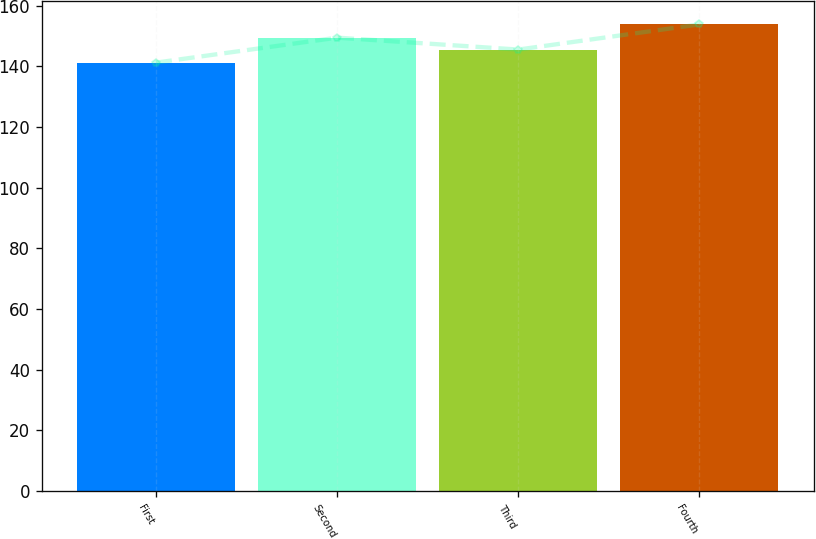Convert chart to OTSL. <chart><loc_0><loc_0><loc_500><loc_500><bar_chart><fcel>First<fcel>Second<fcel>Third<fcel>Fourth<nl><fcel>141.26<fcel>149.5<fcel>145.57<fcel>153.86<nl></chart> 